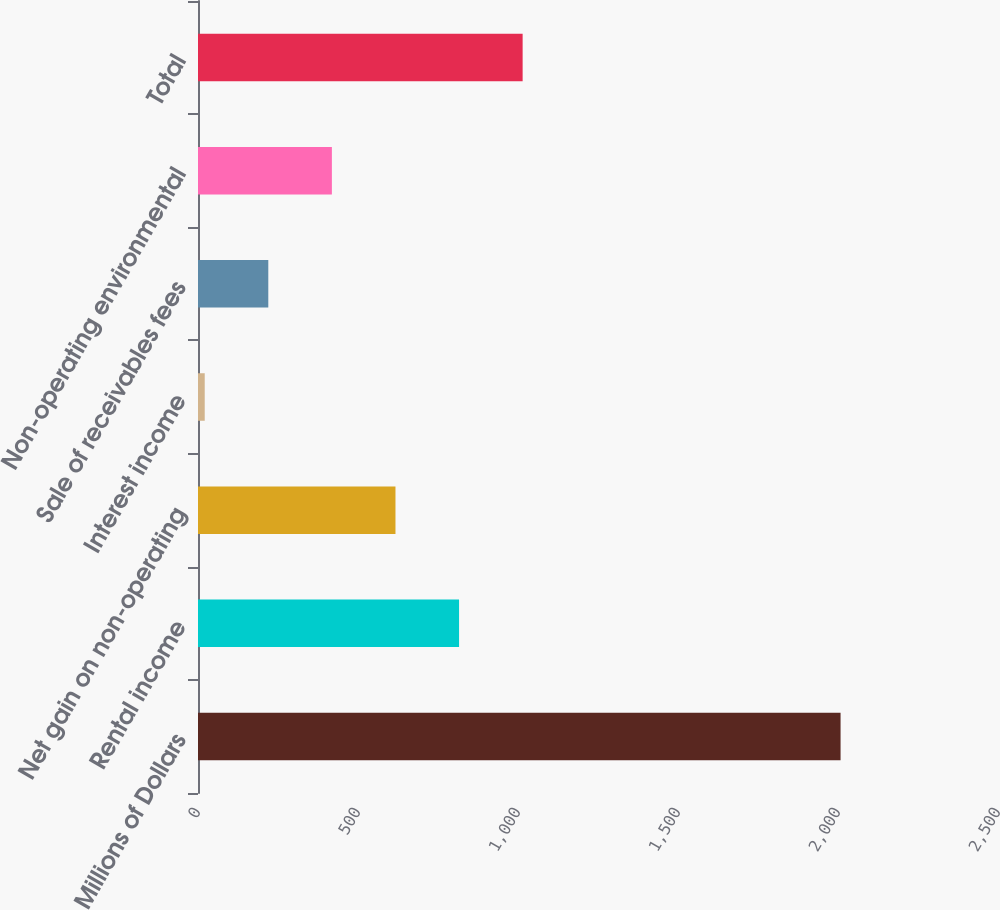Convert chart to OTSL. <chart><loc_0><loc_0><loc_500><loc_500><bar_chart><fcel>Millions of Dollars<fcel>Rental income<fcel>Net gain on non-operating<fcel>Interest income<fcel>Sale of receivables fees<fcel>Non-operating environmental<fcel>Total<nl><fcel>2008<fcel>815.8<fcel>617.1<fcel>21<fcel>219.7<fcel>418.4<fcel>1014.5<nl></chart> 